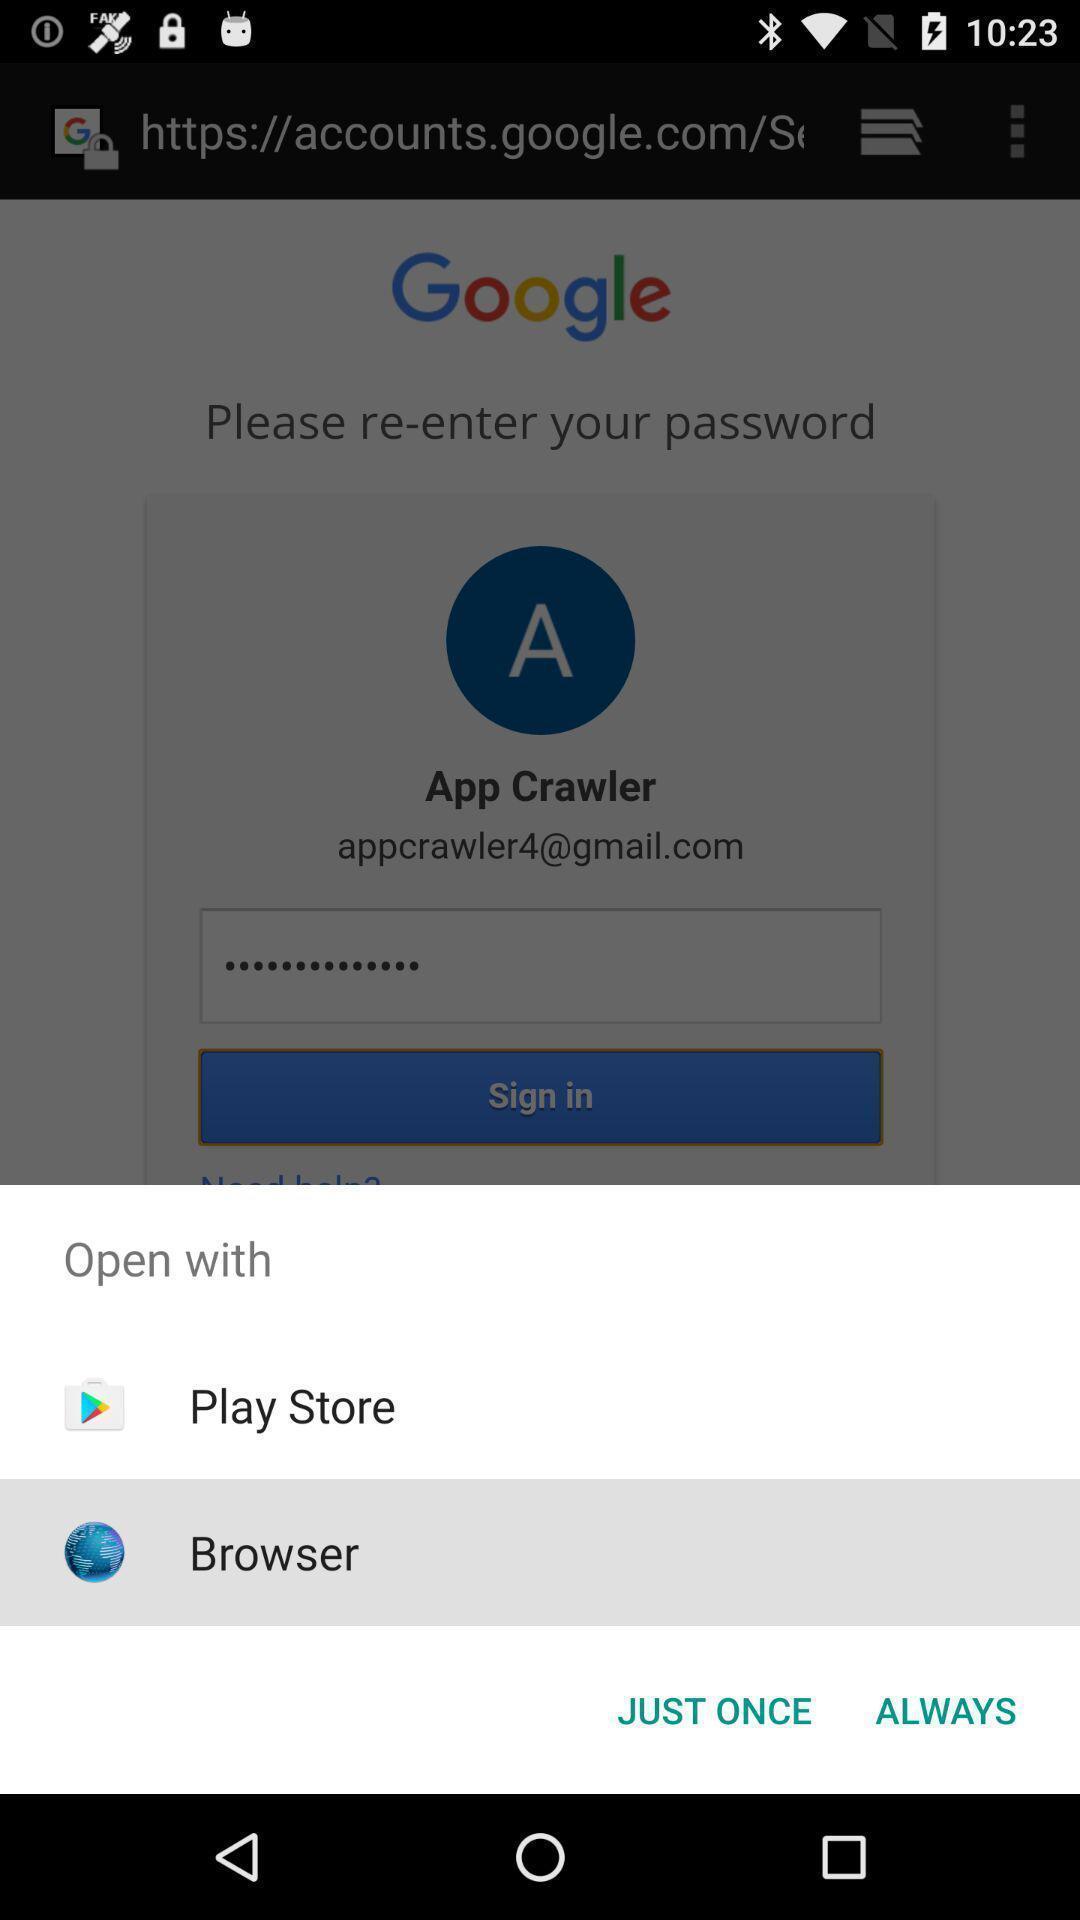Describe this image in words. Pop-up widget displaying two browsing options. 